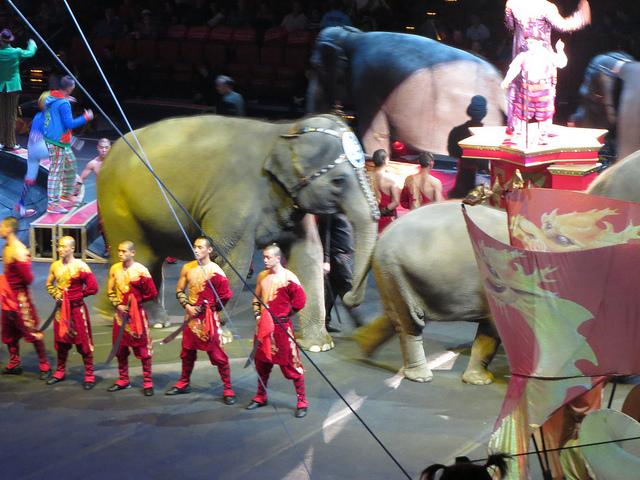What color is the man on the left wearing?
Write a very short answer. Red. How many elephants are there?
Give a very brief answer. 5. How many people are there?
Answer briefly. 13. 